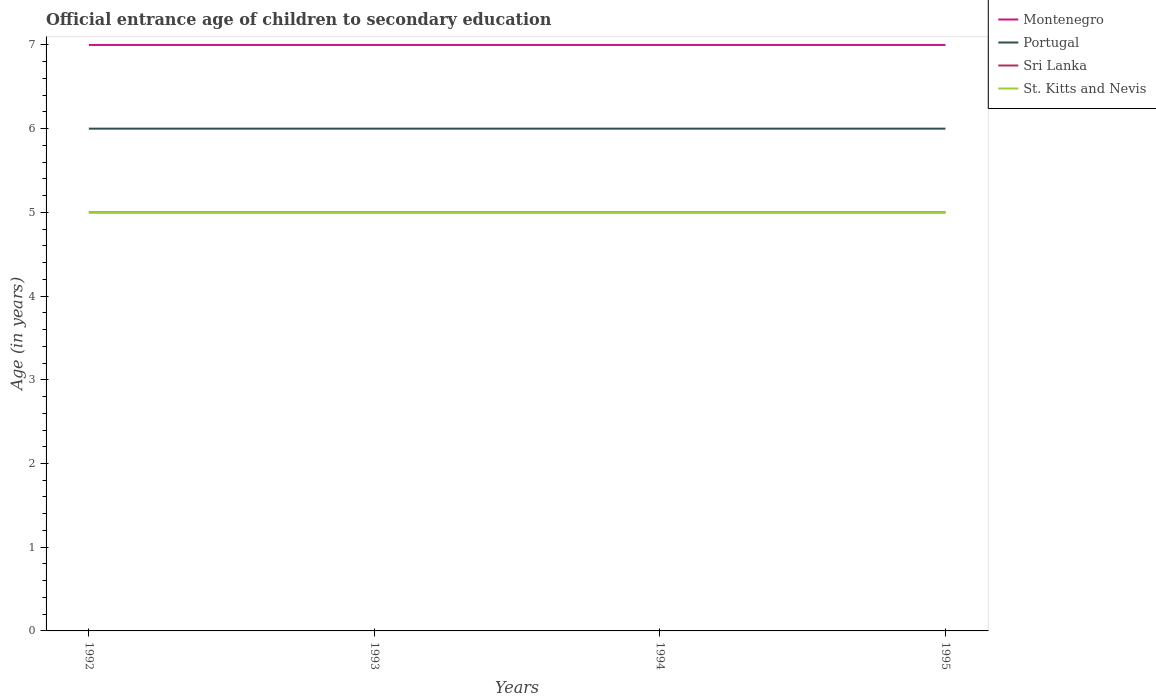Does the line corresponding to Portugal intersect with the line corresponding to Sri Lanka?
Keep it short and to the point. No. Is the number of lines equal to the number of legend labels?
Your answer should be very brief. Yes. In which year was the secondary school starting age of children in Portugal maximum?
Provide a short and direct response. 1992. What is the total secondary school starting age of children in Montenegro in the graph?
Give a very brief answer. 0. How many lines are there?
Provide a succinct answer. 4. What is the difference between two consecutive major ticks on the Y-axis?
Provide a short and direct response. 1. Are the values on the major ticks of Y-axis written in scientific E-notation?
Ensure brevity in your answer.  No. Does the graph contain grids?
Offer a very short reply. No. How many legend labels are there?
Your answer should be compact. 4. How are the legend labels stacked?
Make the answer very short. Vertical. What is the title of the graph?
Keep it short and to the point. Official entrance age of children to secondary education. Does "Belarus" appear as one of the legend labels in the graph?
Make the answer very short. No. What is the label or title of the Y-axis?
Give a very brief answer. Age (in years). What is the Age (in years) of Montenegro in 1992?
Your answer should be very brief. 7. What is the Age (in years) of Portugal in 1992?
Provide a succinct answer. 6. What is the Age (in years) in Portugal in 1993?
Give a very brief answer. 6. What is the Age (in years) in Sri Lanka in 1993?
Make the answer very short. 5. What is the Age (in years) in St. Kitts and Nevis in 1993?
Offer a very short reply. 5. What is the Age (in years) of Portugal in 1995?
Give a very brief answer. 6. What is the Age (in years) of Sri Lanka in 1995?
Your response must be concise. 5. What is the Age (in years) of St. Kitts and Nevis in 1995?
Keep it short and to the point. 5. Across all years, what is the maximum Age (in years) of Montenegro?
Your response must be concise. 7. Across all years, what is the maximum Age (in years) of St. Kitts and Nevis?
Give a very brief answer. 5. Across all years, what is the minimum Age (in years) of Montenegro?
Keep it short and to the point. 7. Across all years, what is the minimum Age (in years) of Sri Lanka?
Offer a terse response. 5. What is the total Age (in years) in Portugal in the graph?
Make the answer very short. 24. What is the difference between the Age (in years) in Sri Lanka in 1992 and that in 1993?
Give a very brief answer. 0. What is the difference between the Age (in years) of St. Kitts and Nevis in 1992 and that in 1993?
Provide a short and direct response. 0. What is the difference between the Age (in years) of Portugal in 1992 and that in 1994?
Give a very brief answer. 0. What is the difference between the Age (in years) of Sri Lanka in 1992 and that in 1994?
Provide a short and direct response. 0. What is the difference between the Age (in years) in St. Kitts and Nevis in 1992 and that in 1994?
Your answer should be compact. 0. What is the difference between the Age (in years) of Montenegro in 1993 and that in 1994?
Make the answer very short. 0. What is the difference between the Age (in years) of Sri Lanka in 1993 and that in 1994?
Provide a succinct answer. 0. What is the difference between the Age (in years) in St. Kitts and Nevis in 1993 and that in 1994?
Keep it short and to the point. 0. What is the difference between the Age (in years) in Portugal in 1993 and that in 1995?
Make the answer very short. 0. What is the difference between the Age (in years) of Sri Lanka in 1993 and that in 1995?
Offer a very short reply. 0. What is the difference between the Age (in years) of Portugal in 1994 and that in 1995?
Give a very brief answer. 0. What is the difference between the Age (in years) of Sri Lanka in 1994 and that in 1995?
Provide a succinct answer. 0. What is the difference between the Age (in years) in Montenegro in 1992 and the Age (in years) in Portugal in 1993?
Make the answer very short. 1. What is the difference between the Age (in years) in Portugal in 1992 and the Age (in years) in St. Kitts and Nevis in 1993?
Offer a very short reply. 1. What is the difference between the Age (in years) of Sri Lanka in 1992 and the Age (in years) of St. Kitts and Nevis in 1993?
Keep it short and to the point. 0. What is the difference between the Age (in years) in Montenegro in 1992 and the Age (in years) in Portugal in 1994?
Your answer should be very brief. 1. What is the difference between the Age (in years) in Portugal in 1992 and the Age (in years) in Sri Lanka in 1994?
Offer a very short reply. 1. What is the difference between the Age (in years) in Portugal in 1992 and the Age (in years) in St. Kitts and Nevis in 1994?
Your response must be concise. 1. What is the difference between the Age (in years) in Montenegro in 1992 and the Age (in years) in Sri Lanka in 1995?
Keep it short and to the point. 2. What is the difference between the Age (in years) in Montenegro in 1992 and the Age (in years) in St. Kitts and Nevis in 1995?
Keep it short and to the point. 2. What is the difference between the Age (in years) of Montenegro in 1993 and the Age (in years) of Sri Lanka in 1994?
Ensure brevity in your answer.  2. What is the difference between the Age (in years) in Montenegro in 1993 and the Age (in years) in St. Kitts and Nevis in 1994?
Give a very brief answer. 2. What is the difference between the Age (in years) in Portugal in 1993 and the Age (in years) in Sri Lanka in 1994?
Keep it short and to the point. 1. What is the difference between the Age (in years) in Portugal in 1993 and the Age (in years) in St. Kitts and Nevis in 1994?
Provide a succinct answer. 1. What is the difference between the Age (in years) in Sri Lanka in 1993 and the Age (in years) in St. Kitts and Nevis in 1994?
Give a very brief answer. 0. What is the difference between the Age (in years) of Montenegro in 1993 and the Age (in years) of Portugal in 1995?
Offer a terse response. 1. What is the difference between the Age (in years) in Montenegro in 1993 and the Age (in years) in Sri Lanka in 1995?
Give a very brief answer. 2. What is the difference between the Age (in years) in Montenegro in 1993 and the Age (in years) in St. Kitts and Nevis in 1995?
Provide a succinct answer. 2. What is the difference between the Age (in years) of Portugal in 1993 and the Age (in years) of St. Kitts and Nevis in 1995?
Keep it short and to the point. 1. What is the difference between the Age (in years) in Montenegro in 1994 and the Age (in years) in St. Kitts and Nevis in 1995?
Offer a very short reply. 2. What is the difference between the Age (in years) of Portugal in 1994 and the Age (in years) of St. Kitts and Nevis in 1995?
Your answer should be compact. 1. What is the average Age (in years) of Montenegro per year?
Make the answer very short. 7. What is the average Age (in years) in Portugal per year?
Offer a terse response. 6. What is the average Age (in years) of Sri Lanka per year?
Give a very brief answer. 5. What is the average Age (in years) of St. Kitts and Nevis per year?
Offer a very short reply. 5. In the year 1992, what is the difference between the Age (in years) of Montenegro and Age (in years) of Portugal?
Your answer should be very brief. 1. In the year 1992, what is the difference between the Age (in years) in Montenegro and Age (in years) in St. Kitts and Nevis?
Ensure brevity in your answer.  2. In the year 1992, what is the difference between the Age (in years) in Portugal and Age (in years) in Sri Lanka?
Ensure brevity in your answer.  1. In the year 1992, what is the difference between the Age (in years) in Sri Lanka and Age (in years) in St. Kitts and Nevis?
Provide a succinct answer. 0. In the year 1993, what is the difference between the Age (in years) of Portugal and Age (in years) of Sri Lanka?
Provide a succinct answer. 1. In the year 1993, what is the difference between the Age (in years) in Sri Lanka and Age (in years) in St. Kitts and Nevis?
Offer a very short reply. 0. In the year 1994, what is the difference between the Age (in years) in Montenegro and Age (in years) in Portugal?
Offer a very short reply. 1. In the year 1994, what is the difference between the Age (in years) in Portugal and Age (in years) in Sri Lanka?
Your response must be concise. 1. In the year 1994, what is the difference between the Age (in years) of Portugal and Age (in years) of St. Kitts and Nevis?
Your response must be concise. 1. In the year 1995, what is the difference between the Age (in years) in Montenegro and Age (in years) in St. Kitts and Nevis?
Provide a short and direct response. 2. In the year 1995, what is the difference between the Age (in years) in Portugal and Age (in years) in St. Kitts and Nevis?
Your response must be concise. 1. What is the ratio of the Age (in years) in Montenegro in 1992 to that in 1993?
Give a very brief answer. 1. What is the ratio of the Age (in years) in Portugal in 1992 to that in 1993?
Your answer should be compact. 1. What is the ratio of the Age (in years) of Sri Lanka in 1992 to that in 1993?
Ensure brevity in your answer.  1. What is the ratio of the Age (in years) in Portugal in 1992 to that in 1995?
Your answer should be very brief. 1. What is the ratio of the Age (in years) in St. Kitts and Nevis in 1992 to that in 1995?
Make the answer very short. 1. What is the ratio of the Age (in years) in Montenegro in 1993 to that in 1994?
Your response must be concise. 1. What is the ratio of the Age (in years) of Portugal in 1993 to that in 1994?
Your response must be concise. 1. What is the ratio of the Age (in years) of St. Kitts and Nevis in 1993 to that in 1994?
Provide a short and direct response. 1. What is the ratio of the Age (in years) of Portugal in 1993 to that in 1995?
Make the answer very short. 1. What is the ratio of the Age (in years) of Sri Lanka in 1993 to that in 1995?
Ensure brevity in your answer.  1. What is the ratio of the Age (in years) of Montenegro in 1994 to that in 1995?
Your response must be concise. 1. What is the ratio of the Age (in years) of St. Kitts and Nevis in 1994 to that in 1995?
Make the answer very short. 1. What is the difference between the highest and the lowest Age (in years) of Montenegro?
Ensure brevity in your answer.  0. What is the difference between the highest and the lowest Age (in years) of Portugal?
Provide a short and direct response. 0. 